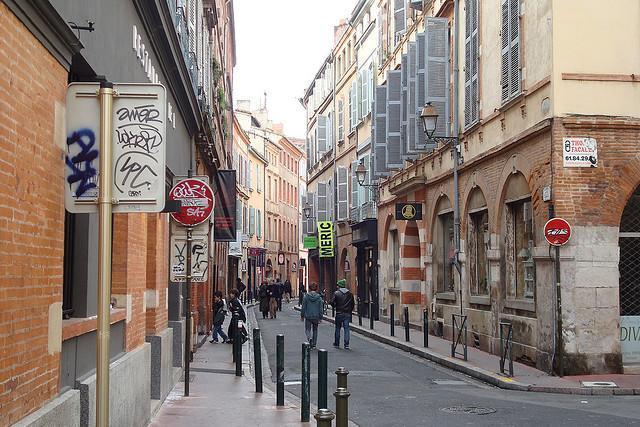How many lights on the building?
Give a very brief answer. 2. 